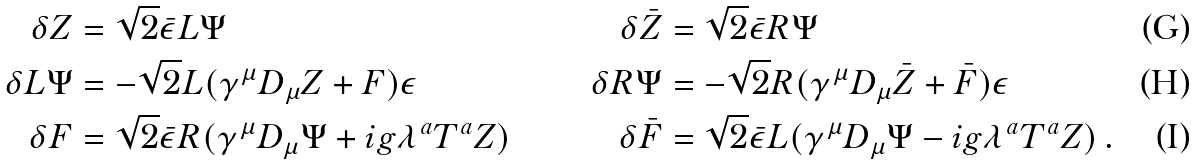Convert formula to latex. <formula><loc_0><loc_0><loc_500><loc_500>\delta Z & = \sqrt { 2 } \bar { \epsilon } L \Psi & \delta \bar { Z } & = \sqrt { 2 } \bar { \epsilon } R \Psi \\ \delta L \Psi & = - \sqrt { 2 } L ( \gamma ^ { \mu } D _ { \mu } Z + F ) \epsilon & \delta R \Psi & = - \sqrt { 2 } R ( \gamma ^ { \mu } D _ { \mu } \bar { Z } + \bar { F } ) \epsilon \\ \delta F & = \sqrt { 2 } \bar { \epsilon } R ( \gamma ^ { \mu } D _ { \mu } \Psi + i g \lambda ^ { a } T ^ { a } Z ) & \delta \bar { F } & = \sqrt { 2 } \bar { \epsilon } L ( \gamma ^ { \mu } D _ { \mu } \Psi - i g \lambda ^ { a } T ^ { a } Z ) \, .</formula> 